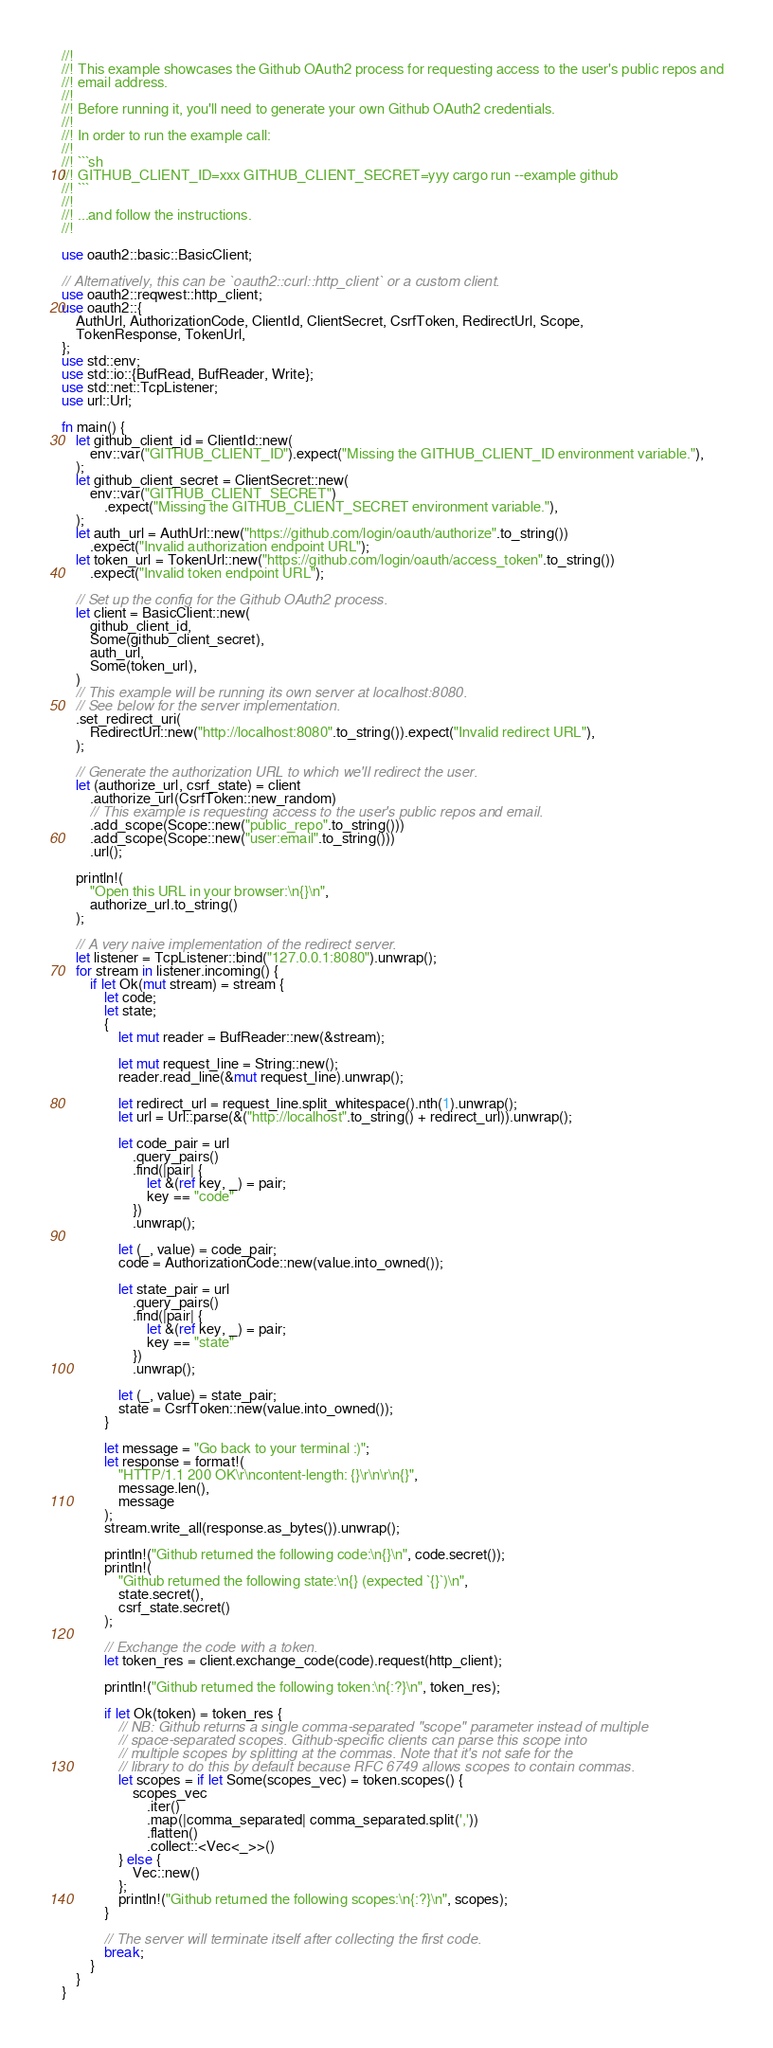Convert code to text. <code><loc_0><loc_0><loc_500><loc_500><_Rust_>//!
//! This example showcases the Github OAuth2 process for requesting access to the user's public repos and
//! email address.
//!
//! Before running it, you'll need to generate your own Github OAuth2 credentials.
//!
//! In order to run the example call:
//!
//! ```sh
//! GITHUB_CLIENT_ID=xxx GITHUB_CLIENT_SECRET=yyy cargo run --example github
//! ```
//!
//! ...and follow the instructions.
//!

use oauth2::basic::BasicClient;

// Alternatively, this can be `oauth2::curl::http_client` or a custom client.
use oauth2::reqwest::http_client;
use oauth2::{
    AuthUrl, AuthorizationCode, ClientId, ClientSecret, CsrfToken, RedirectUrl, Scope,
    TokenResponse, TokenUrl,
};
use std::env;
use std::io::{BufRead, BufReader, Write};
use std::net::TcpListener;
use url::Url;

fn main() {
    let github_client_id = ClientId::new(
        env::var("GITHUB_CLIENT_ID").expect("Missing the GITHUB_CLIENT_ID environment variable."),
    );
    let github_client_secret = ClientSecret::new(
        env::var("GITHUB_CLIENT_SECRET")
            .expect("Missing the GITHUB_CLIENT_SECRET environment variable."),
    );
    let auth_url = AuthUrl::new("https://github.com/login/oauth/authorize".to_string())
        .expect("Invalid authorization endpoint URL");
    let token_url = TokenUrl::new("https://github.com/login/oauth/access_token".to_string())
        .expect("Invalid token endpoint URL");

    // Set up the config for the Github OAuth2 process.
    let client = BasicClient::new(
        github_client_id,
        Some(github_client_secret),
        auth_url,
        Some(token_url),
    )
    // This example will be running its own server at localhost:8080.
    // See below for the server implementation.
    .set_redirect_uri(
        RedirectUrl::new("http://localhost:8080".to_string()).expect("Invalid redirect URL"),
    );

    // Generate the authorization URL to which we'll redirect the user.
    let (authorize_url, csrf_state) = client
        .authorize_url(CsrfToken::new_random)
        // This example is requesting access to the user's public repos and email.
        .add_scope(Scope::new("public_repo".to_string()))
        .add_scope(Scope::new("user:email".to_string()))
        .url();

    println!(
        "Open this URL in your browser:\n{}\n",
        authorize_url.to_string()
    );

    // A very naive implementation of the redirect server.
    let listener = TcpListener::bind("127.0.0.1:8080").unwrap();
    for stream in listener.incoming() {
        if let Ok(mut stream) = stream {
            let code;
            let state;
            {
                let mut reader = BufReader::new(&stream);

                let mut request_line = String::new();
                reader.read_line(&mut request_line).unwrap();

                let redirect_url = request_line.split_whitespace().nth(1).unwrap();
                let url = Url::parse(&("http://localhost".to_string() + redirect_url)).unwrap();

                let code_pair = url
                    .query_pairs()
                    .find(|pair| {
                        let &(ref key, _) = pair;
                        key == "code"
                    })
                    .unwrap();

                let (_, value) = code_pair;
                code = AuthorizationCode::new(value.into_owned());

                let state_pair = url
                    .query_pairs()
                    .find(|pair| {
                        let &(ref key, _) = pair;
                        key == "state"
                    })
                    .unwrap();

                let (_, value) = state_pair;
                state = CsrfToken::new(value.into_owned());
            }

            let message = "Go back to your terminal :)";
            let response = format!(
                "HTTP/1.1 200 OK\r\ncontent-length: {}\r\n\r\n{}",
                message.len(),
                message
            );
            stream.write_all(response.as_bytes()).unwrap();

            println!("Github returned the following code:\n{}\n", code.secret());
            println!(
                "Github returned the following state:\n{} (expected `{}`)\n",
                state.secret(),
                csrf_state.secret()
            );

            // Exchange the code with a token.
            let token_res = client.exchange_code(code).request(http_client);

            println!("Github returned the following token:\n{:?}\n", token_res);

            if let Ok(token) = token_res {
                // NB: Github returns a single comma-separated "scope" parameter instead of multiple
                // space-separated scopes. Github-specific clients can parse this scope into
                // multiple scopes by splitting at the commas. Note that it's not safe for the
                // library to do this by default because RFC 6749 allows scopes to contain commas.
                let scopes = if let Some(scopes_vec) = token.scopes() {
                    scopes_vec
                        .iter()
                        .map(|comma_separated| comma_separated.split(','))
                        .flatten()
                        .collect::<Vec<_>>()
                } else {
                    Vec::new()
                };
                println!("Github returned the following scopes:\n{:?}\n", scopes);
            }

            // The server will terminate itself after collecting the first code.
            break;
        }
    }
}
</code> 